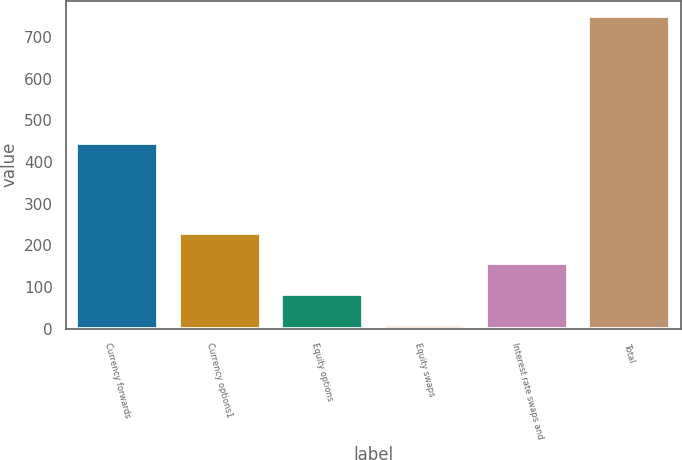<chart> <loc_0><loc_0><loc_500><loc_500><bar_chart><fcel>Currency forwards<fcel>Currency options1<fcel>Equity options<fcel>Equity swaps<fcel>Interest rate swaps and<fcel>Total<nl><fcel>446<fcel>230.6<fcel>82.2<fcel>8<fcel>156.4<fcel>750<nl></chart> 